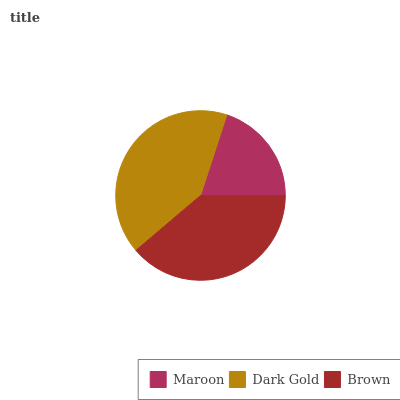Is Maroon the minimum?
Answer yes or no. Yes. Is Dark Gold the maximum?
Answer yes or no. Yes. Is Brown the minimum?
Answer yes or no. No. Is Brown the maximum?
Answer yes or no. No. Is Dark Gold greater than Brown?
Answer yes or no. Yes. Is Brown less than Dark Gold?
Answer yes or no. Yes. Is Brown greater than Dark Gold?
Answer yes or no. No. Is Dark Gold less than Brown?
Answer yes or no. No. Is Brown the high median?
Answer yes or no. Yes. Is Brown the low median?
Answer yes or no. Yes. Is Maroon the high median?
Answer yes or no. No. Is Maroon the low median?
Answer yes or no. No. 